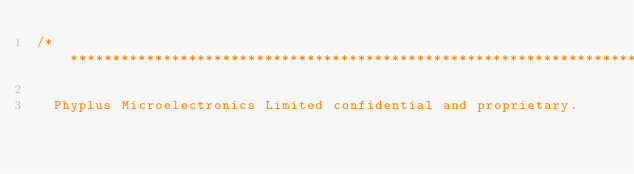Convert code to text. <code><loc_0><loc_0><loc_500><loc_500><_C_>/**************************************************************************************************
 
  Phyplus Microelectronics Limited confidential and proprietary. </code> 